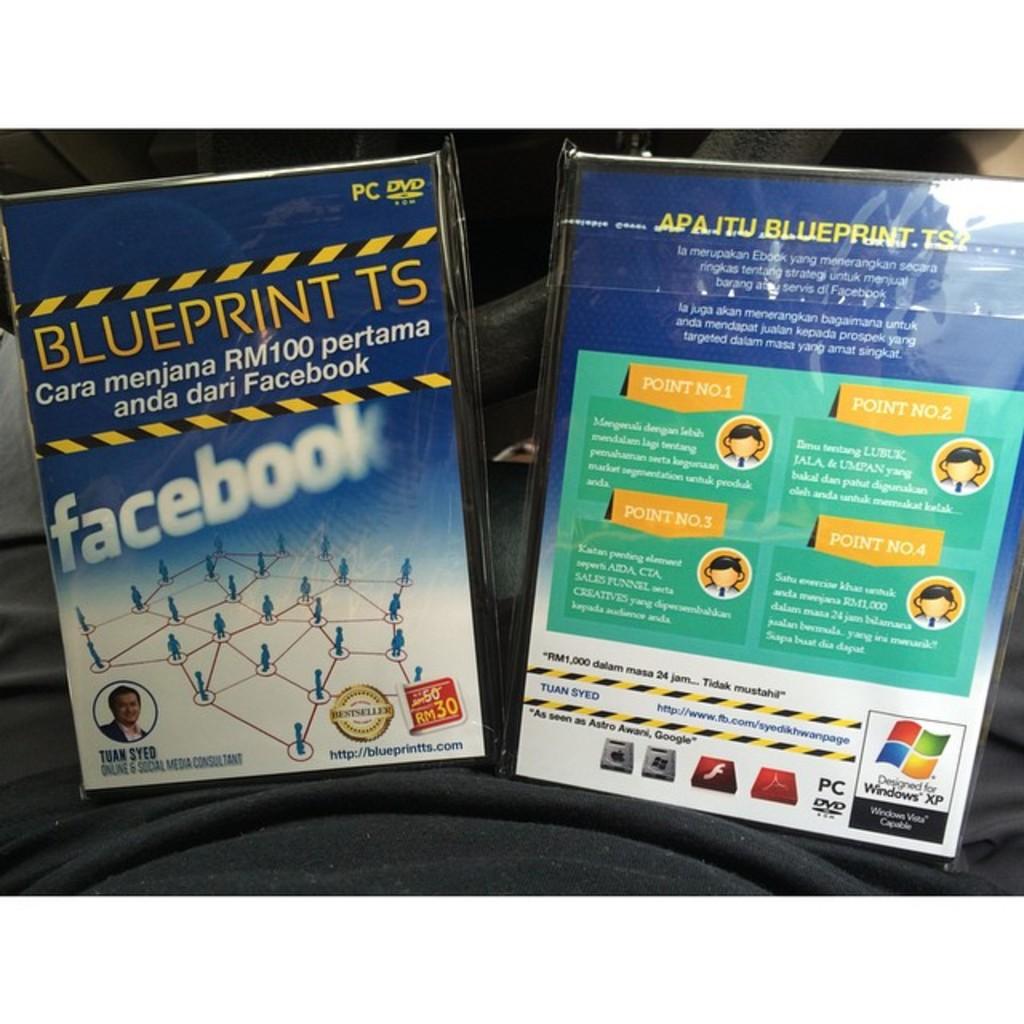What social media platform is mentioned?
Keep it short and to the point. Facebook. What is the name of the software?
Offer a very short reply. Blueprint ts. 